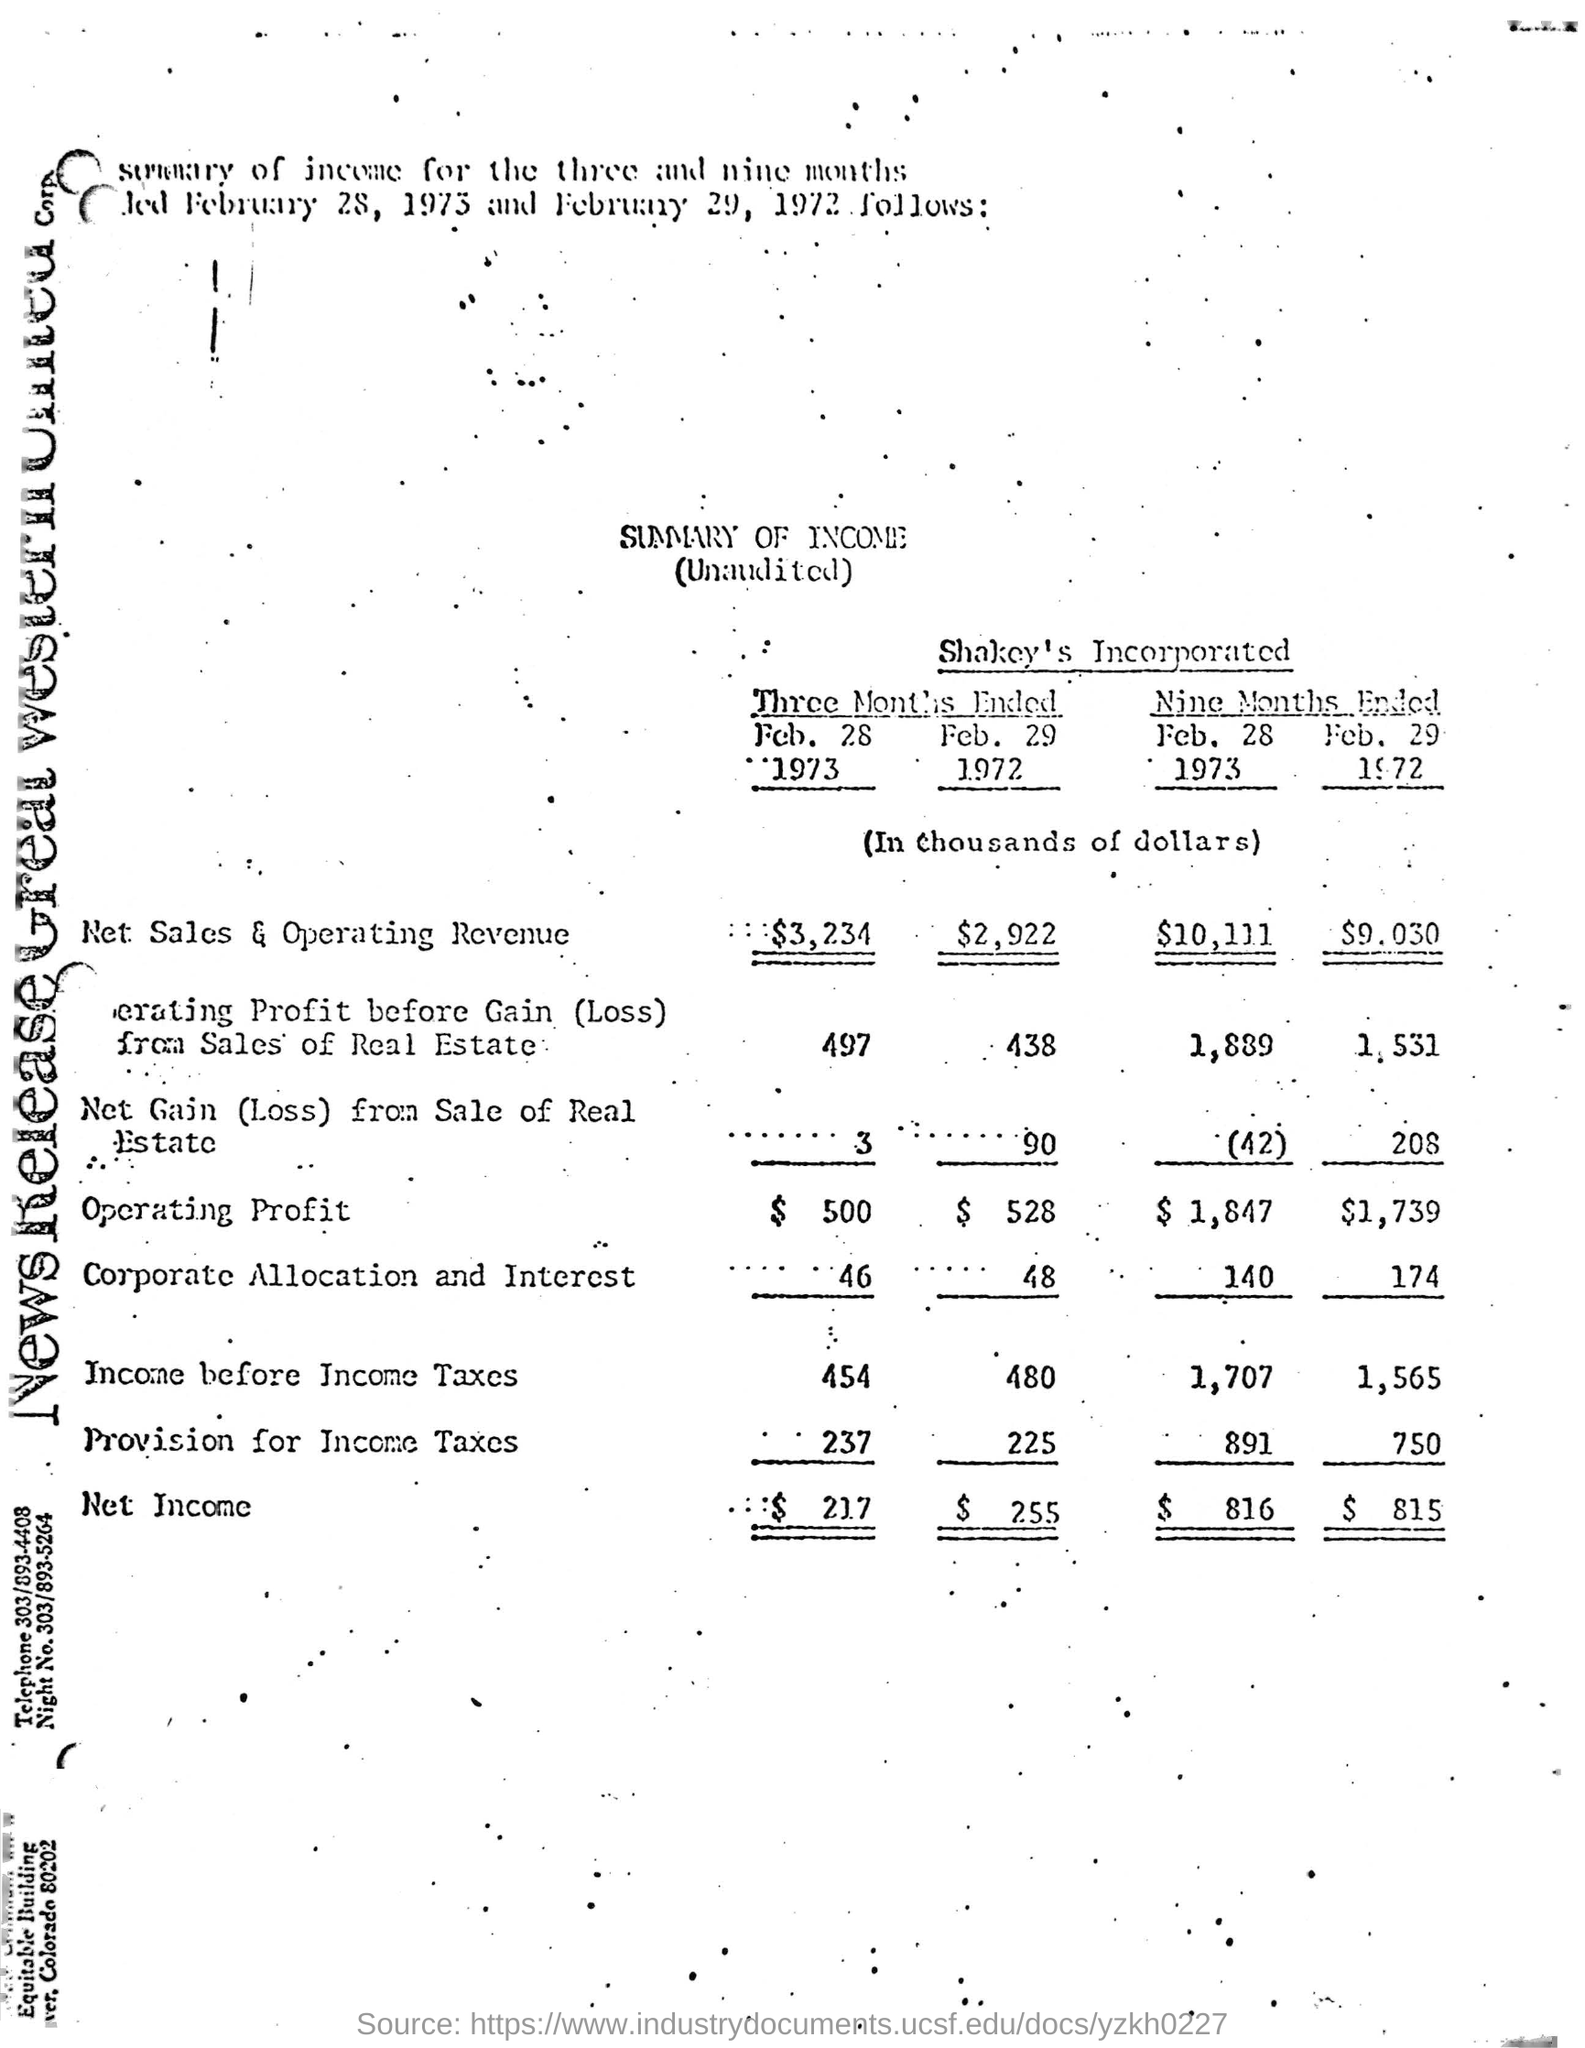Indicate a few pertinent items in this graphic. The figures and amounts provided were in a specific currency, and it is unknown whether they were expressed in dollars or another currency. 